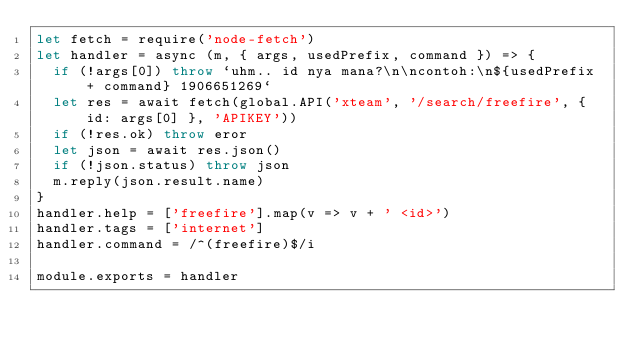<code> <loc_0><loc_0><loc_500><loc_500><_JavaScript_>let fetch = require('node-fetch')
let handler = async (m, { args, usedPrefix, command }) => {
  if (!args[0]) throw `uhm.. id nya mana?\n\ncontoh:\n${usedPrefix + command} 1906651269`
  let res = await fetch(global.API('xteam', '/search/freefire', { id: args[0] }, 'APIKEY'))
  if (!res.ok) throw eror
  let json = await res.json()
  if (!json.status) throw json
  m.reply(json.result.name)
}
handler.help = ['freefire'].map(v => v + ' <id>')
handler.tags = ['internet']
handler.command = /^(freefire)$/i

module.exports = handler
</code> 